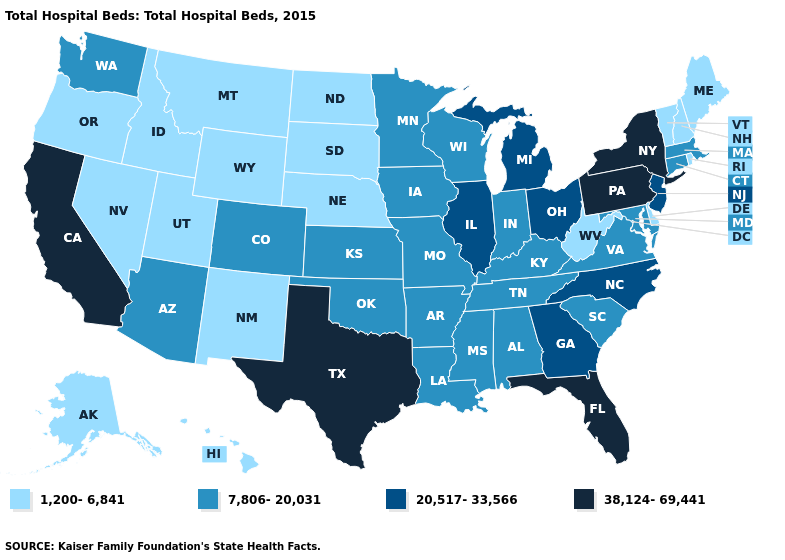What is the highest value in the South ?
Give a very brief answer. 38,124-69,441. What is the highest value in the USA?
Write a very short answer. 38,124-69,441. Does Connecticut have the lowest value in the Northeast?
Write a very short answer. No. What is the value of South Dakota?
Short answer required. 1,200-6,841. What is the lowest value in the MidWest?
Keep it brief. 1,200-6,841. What is the value of Oklahoma?
Give a very brief answer. 7,806-20,031. What is the value of Delaware?
Quick response, please. 1,200-6,841. What is the highest value in states that border North Dakota?
Write a very short answer. 7,806-20,031. Does Utah have a lower value than Maryland?
Short answer required. Yes. Does New Hampshire have the lowest value in the Northeast?
Write a very short answer. Yes. Does the first symbol in the legend represent the smallest category?
Short answer required. Yes. Name the states that have a value in the range 20,517-33,566?
Short answer required. Georgia, Illinois, Michigan, New Jersey, North Carolina, Ohio. How many symbols are there in the legend?
Concise answer only. 4. Which states have the lowest value in the South?
Short answer required. Delaware, West Virginia. 